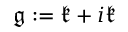Convert formula to latex. <formula><loc_0><loc_0><loc_500><loc_500>{ \mathfrak { g } } \colon = { \mathfrak { k } } + i { \mathfrak { k } }</formula> 